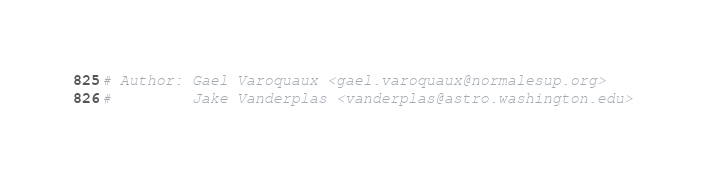<code> <loc_0><loc_0><loc_500><loc_500><_Python_># Author: Gael Varoquaux <gael.varoquaux@normalesup.org>
#         Jake Vanderplas <vanderplas@astro.washington.edu></code> 